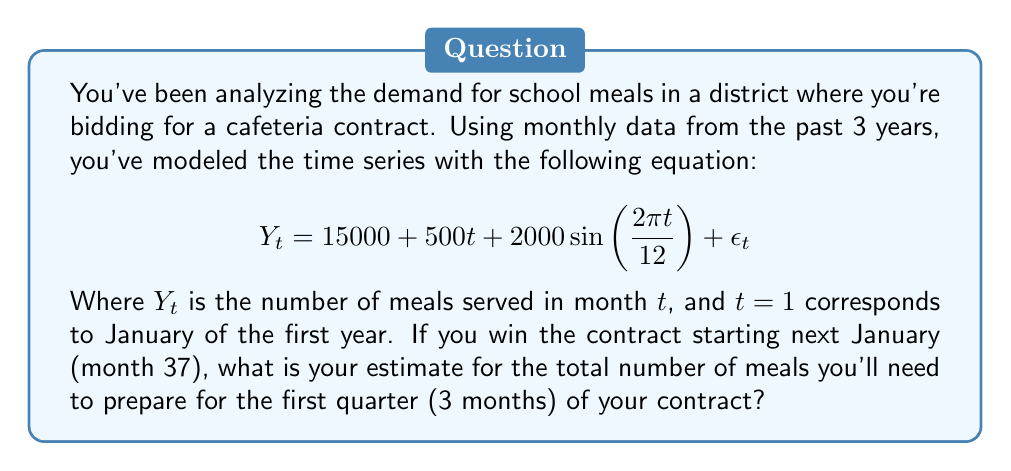Teach me how to tackle this problem. To solve this problem, we need to use the given time series model to forecast the demand for the next three months. Let's break it down step-by-step:

1) The model is composed of three parts:
   - Trend: $15000 + 500t$
   - Seasonality: $2000\sin(\frac{2\pi t}{12})$
   - Random error: $\epsilon_t$ (which we assume to be zero for forecasting)

2) We need to calculate $Y_t$ for $t = 37, 38,$ and $39$ (January, February, and March of the contract year).

3) For January ($t = 37$):
   $$Y_{37} = 15000 + 500(37) + 2000\sin(\frac{2\pi (37)}{12})$$
   $$= 15000 + 18500 + 2000\sin(6.1415\pi)$$
   $$= 33500 + 2000(0) = 33500$$

4) For February ($t = 38$):
   $$Y_{38} = 15000 + 500(38) + 2000\sin(\frac{2\pi (38)}{12})$$
   $$= 15000 + 19000 + 2000\sin(6.3333\pi)$$
   $$= 34000 + 2000(-0.5) = 33000$$

5) For March ($t = 39$):
   $$Y_{39} = 15000 + 500(39) + 2000\sin(\frac{2\pi (39)}{12})$$
   $$= 15000 + 19500 + 2000\sin(6.5\pi)$$
   $$= 34500 + 2000(-0.866) = 32768$$

6) The total number of meals for the quarter is the sum of these three months:
   $$Total = Y_{37} + Y_{38} + Y_{39} = 33500 + 33000 + 32768 = 99268$$

Therefore, the estimated total number of meals for the first quarter is 99,268.
Answer: 99,268 meals 